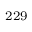Convert formula to latex. <formula><loc_0><loc_0><loc_500><loc_500>^ { 2 2 9 }</formula> 